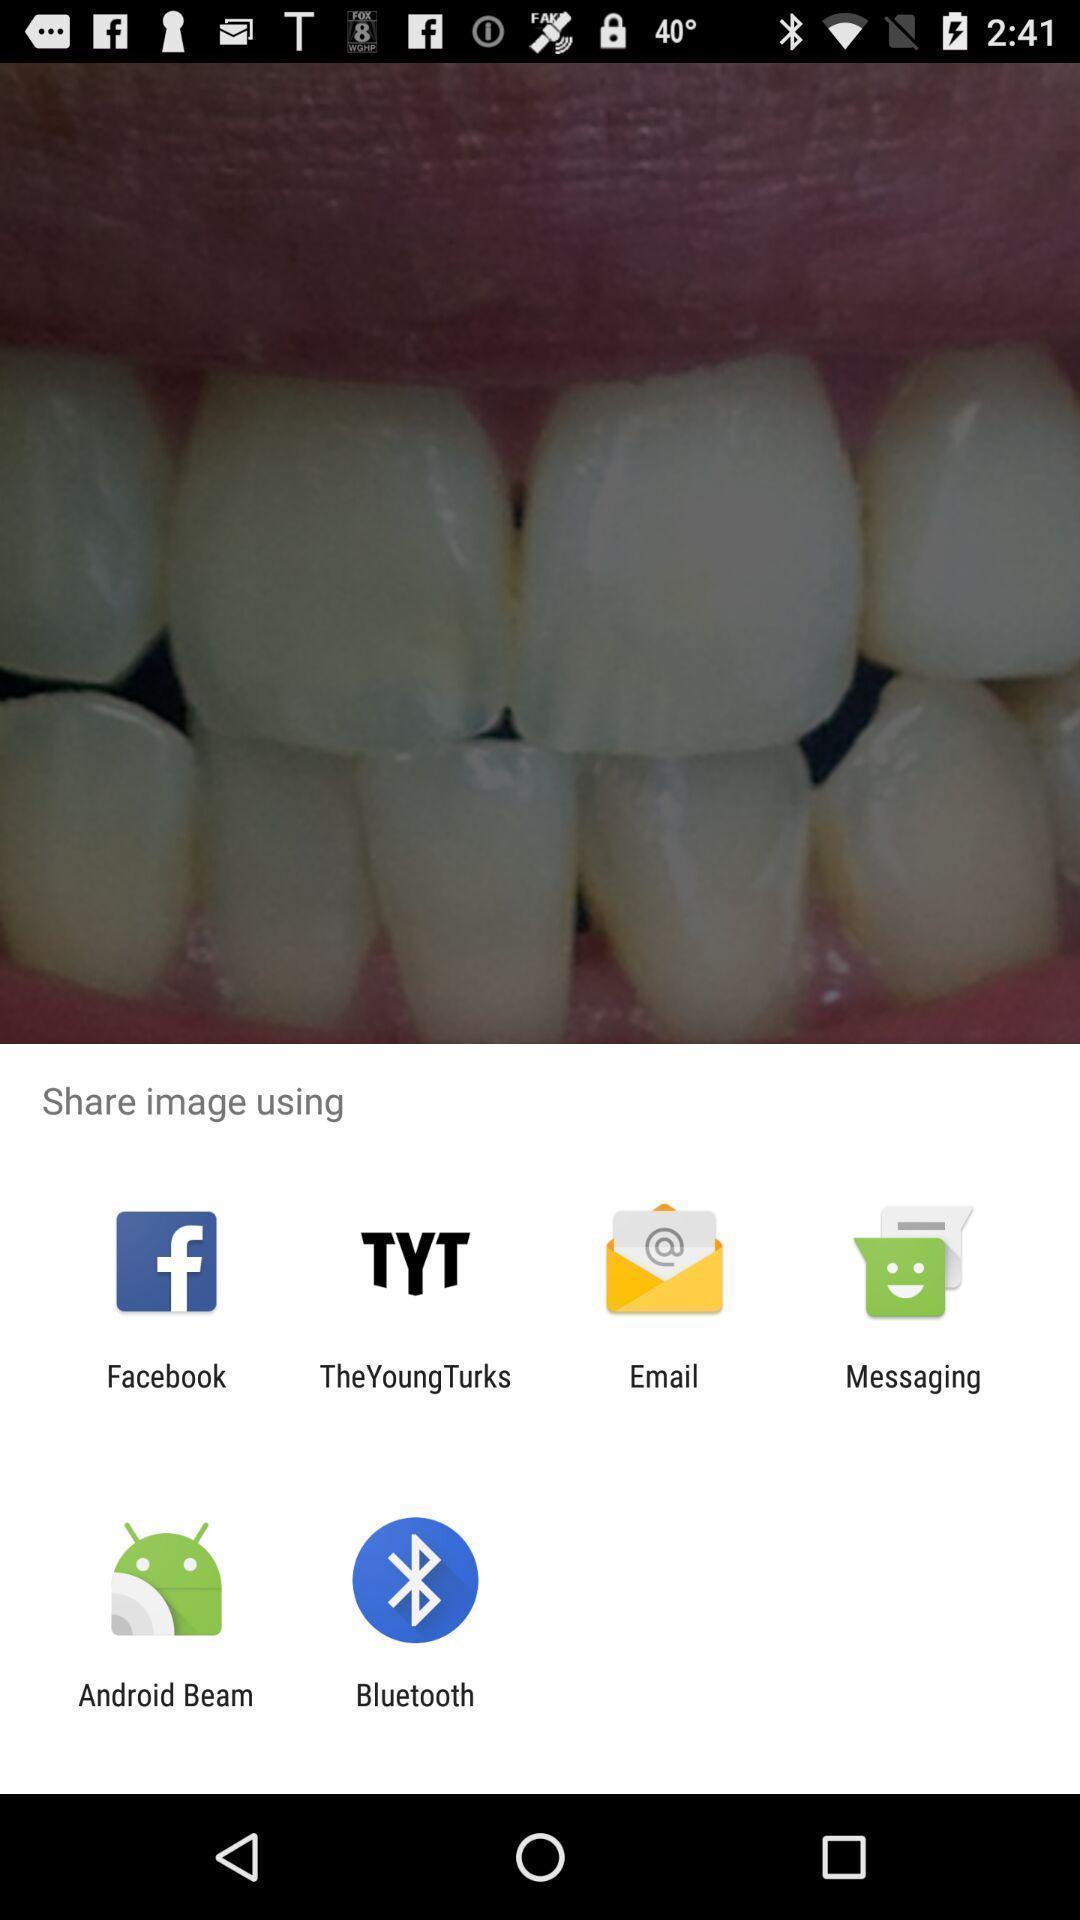Tell me about the visual elements in this screen capture. Popup to share image via different options. 